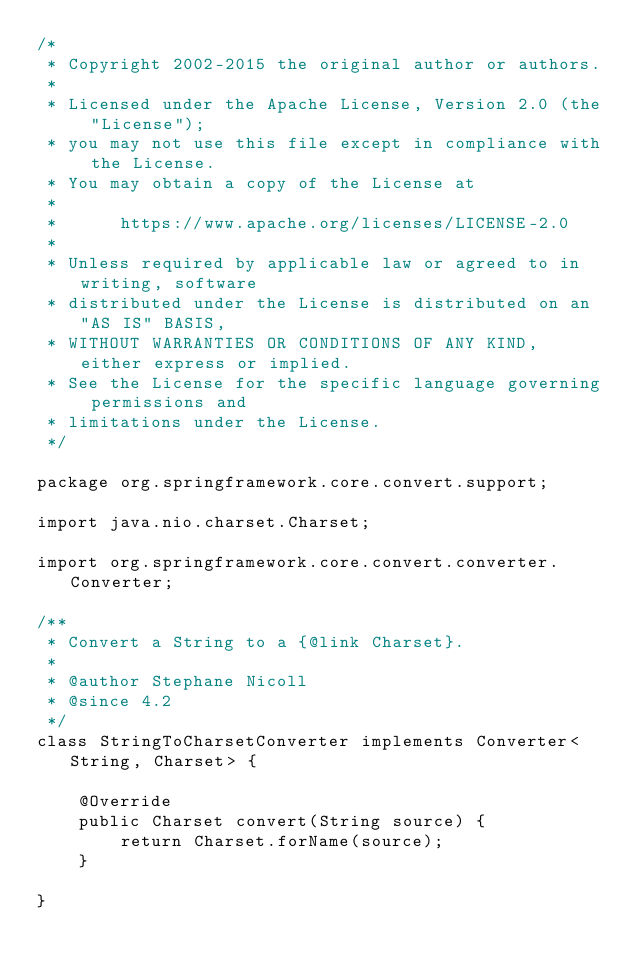Convert code to text. <code><loc_0><loc_0><loc_500><loc_500><_Java_>/*
 * Copyright 2002-2015 the original author or authors.
 *
 * Licensed under the Apache License, Version 2.0 (the "License");
 * you may not use this file except in compliance with the License.
 * You may obtain a copy of the License at
 *
 *      https://www.apache.org/licenses/LICENSE-2.0
 *
 * Unless required by applicable law or agreed to in writing, software
 * distributed under the License is distributed on an "AS IS" BASIS,
 * WITHOUT WARRANTIES OR CONDITIONS OF ANY KIND, either express or implied.
 * See the License for the specific language governing permissions and
 * limitations under the License.
 */

package org.springframework.core.convert.support;

import java.nio.charset.Charset;

import org.springframework.core.convert.converter.Converter;

/**
 * Convert a String to a {@link Charset}.
 *
 * @author Stephane Nicoll
 * @since 4.2
 */
class StringToCharsetConverter implements Converter<String, Charset> {

	@Override
	public Charset convert(String source) {
		return Charset.forName(source);
	}

}
</code> 